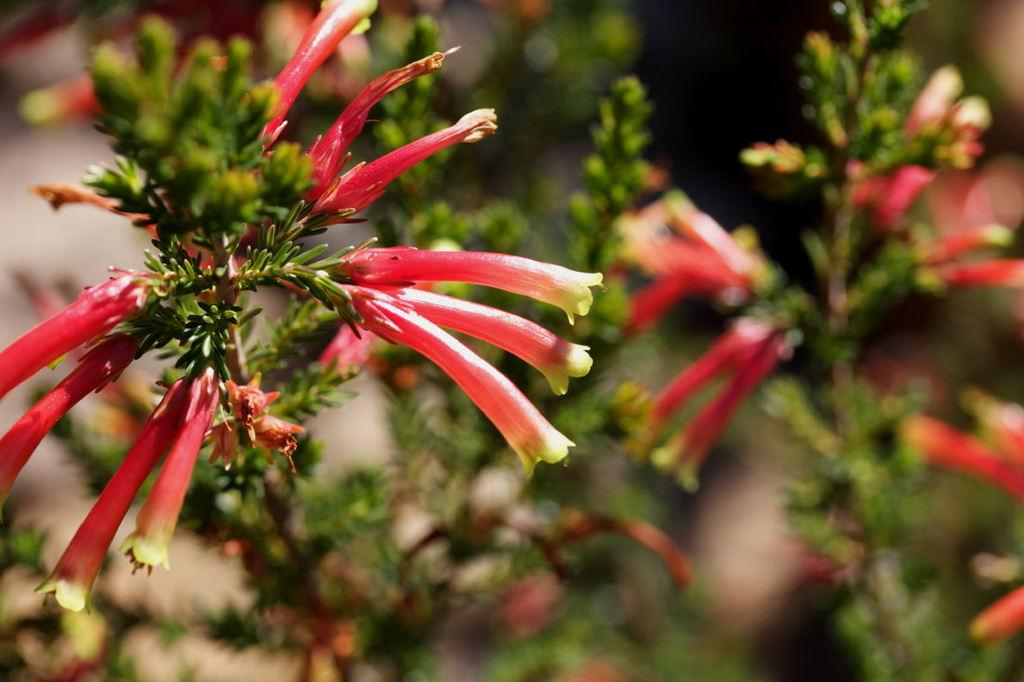What type of flowers can be seen in the image? There are red color flowers in the image. Where are the flowers located? The flowers are on plants. Are there any toys visible among the flowers in the image? There are no toys present among the flowers in the image. Is there a coat hanging on the plants with the flowers? There is no coat visible in the image. 